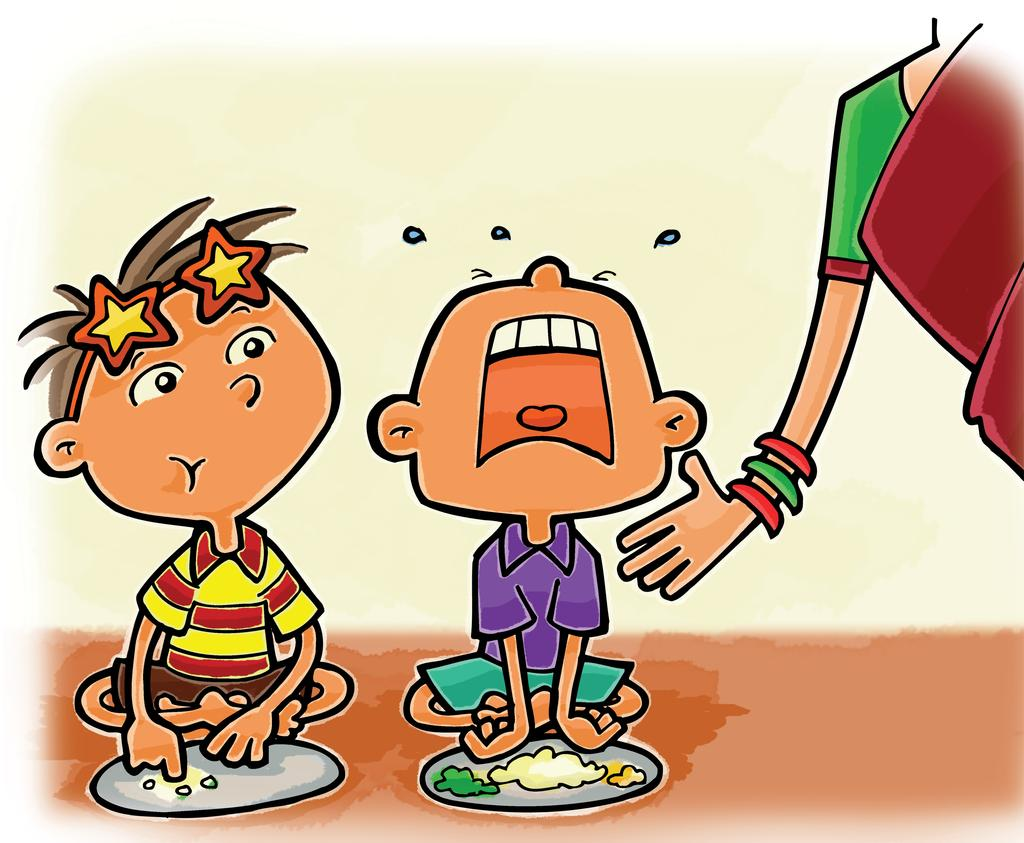What type of artwork is depicted in the image? The image is a drawing. How many children are present in the drawing? There are two children sitting in the drawing. What can be seen in front of the children? There are plates with food items in front of the children. Who else is present in the drawing? There is a lady on the right side of the drawing. What is on the list that the children are holding in the drawing? There is no list present in the drawing; it only features the children, plates with food items, and the lady. 